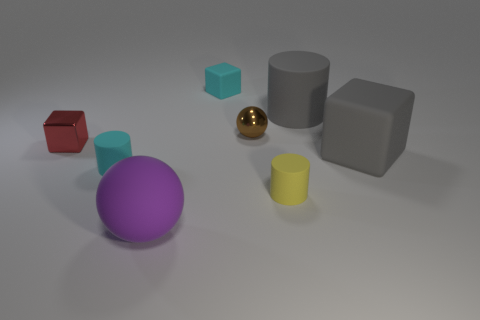What are the different shapes visible in the image? In the image, we can see multiple geometric shapes including a large and small cylinder, a sphere, a cube, and what appears to be a rectangular cuboid. 